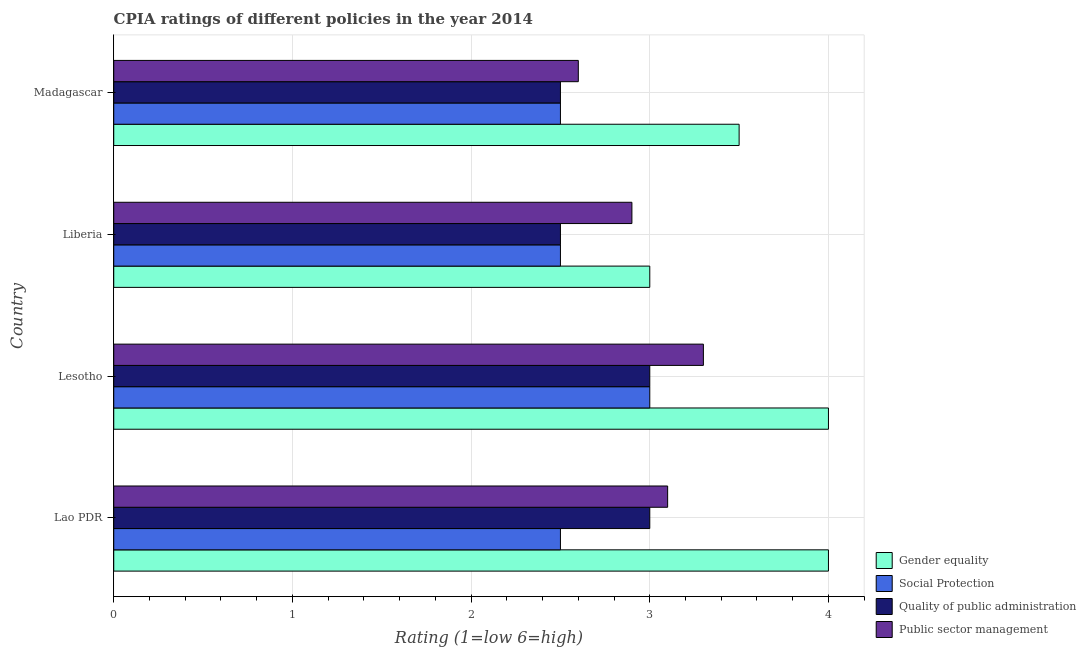How many different coloured bars are there?
Your answer should be compact. 4. How many groups of bars are there?
Make the answer very short. 4. Are the number of bars per tick equal to the number of legend labels?
Provide a short and direct response. Yes. Are the number of bars on each tick of the Y-axis equal?
Give a very brief answer. Yes. What is the label of the 1st group of bars from the top?
Your response must be concise. Madagascar. What is the cpia rating of quality of public administration in Madagascar?
Keep it short and to the point. 2.5. Across all countries, what is the maximum cpia rating of social protection?
Make the answer very short. 3. Across all countries, what is the minimum cpia rating of public sector management?
Give a very brief answer. 2.6. In which country was the cpia rating of gender equality maximum?
Give a very brief answer. Lao PDR. In which country was the cpia rating of social protection minimum?
Make the answer very short. Lao PDR. What is the total cpia rating of public sector management in the graph?
Provide a succinct answer. 11.9. What is the difference between the cpia rating of social protection in Lao PDR and that in Liberia?
Make the answer very short. 0. What is the difference between the cpia rating of social protection in Lao PDR and the cpia rating of public sector management in Liberia?
Offer a terse response. -0.4. What is the average cpia rating of quality of public administration per country?
Give a very brief answer. 2.75. What is the difference between the cpia rating of public sector management and cpia rating of quality of public administration in Lesotho?
Keep it short and to the point. 0.3. In how many countries, is the cpia rating of social protection greater than 0.4 ?
Keep it short and to the point. 4. What is the ratio of the cpia rating of social protection in Liberia to that in Madagascar?
Ensure brevity in your answer.  1. What is the difference between the highest and the second highest cpia rating of social protection?
Give a very brief answer. 0.5. In how many countries, is the cpia rating of quality of public administration greater than the average cpia rating of quality of public administration taken over all countries?
Ensure brevity in your answer.  2. What does the 4th bar from the top in Lesotho represents?
Offer a terse response. Gender equality. What does the 2nd bar from the bottom in Lao PDR represents?
Offer a terse response. Social Protection. Is it the case that in every country, the sum of the cpia rating of gender equality and cpia rating of social protection is greater than the cpia rating of quality of public administration?
Provide a succinct answer. Yes. How many countries are there in the graph?
Keep it short and to the point. 4. Does the graph contain grids?
Offer a terse response. Yes. Where does the legend appear in the graph?
Keep it short and to the point. Bottom right. How many legend labels are there?
Your response must be concise. 4. How are the legend labels stacked?
Give a very brief answer. Vertical. What is the title of the graph?
Ensure brevity in your answer.  CPIA ratings of different policies in the year 2014. What is the label or title of the X-axis?
Keep it short and to the point. Rating (1=low 6=high). What is the label or title of the Y-axis?
Keep it short and to the point. Country. What is the Rating (1=low 6=high) of Quality of public administration in Lao PDR?
Make the answer very short. 3. What is the Rating (1=low 6=high) in Social Protection in Lesotho?
Your answer should be very brief. 3. What is the Rating (1=low 6=high) in Quality of public administration in Lesotho?
Provide a succinct answer. 3. What is the Rating (1=low 6=high) in Gender equality in Liberia?
Your answer should be compact. 3. What is the Rating (1=low 6=high) of Social Protection in Liberia?
Provide a succinct answer. 2.5. What is the Rating (1=low 6=high) in Gender equality in Madagascar?
Give a very brief answer. 3.5. What is the Rating (1=low 6=high) of Social Protection in Madagascar?
Your response must be concise. 2.5. What is the Rating (1=low 6=high) of Quality of public administration in Madagascar?
Your response must be concise. 2.5. Across all countries, what is the maximum Rating (1=low 6=high) of Social Protection?
Your answer should be very brief. 3. Across all countries, what is the maximum Rating (1=low 6=high) in Quality of public administration?
Give a very brief answer. 3. Across all countries, what is the minimum Rating (1=low 6=high) of Social Protection?
Your answer should be very brief. 2.5. Across all countries, what is the minimum Rating (1=low 6=high) of Public sector management?
Your answer should be very brief. 2.6. What is the total Rating (1=low 6=high) of Gender equality in the graph?
Provide a succinct answer. 14.5. What is the total Rating (1=low 6=high) of Quality of public administration in the graph?
Provide a succinct answer. 11. What is the total Rating (1=low 6=high) of Public sector management in the graph?
Provide a short and direct response. 11.9. What is the difference between the Rating (1=low 6=high) in Quality of public administration in Lao PDR and that in Lesotho?
Make the answer very short. 0. What is the difference between the Rating (1=low 6=high) of Public sector management in Lao PDR and that in Lesotho?
Ensure brevity in your answer.  -0.2. What is the difference between the Rating (1=low 6=high) in Gender equality in Lao PDR and that in Liberia?
Offer a very short reply. 1. What is the difference between the Rating (1=low 6=high) in Quality of public administration in Lao PDR and that in Liberia?
Ensure brevity in your answer.  0.5. What is the difference between the Rating (1=low 6=high) of Social Protection in Lao PDR and that in Madagascar?
Your answer should be compact. 0. What is the difference between the Rating (1=low 6=high) of Gender equality in Lesotho and that in Liberia?
Your answer should be very brief. 1. What is the difference between the Rating (1=low 6=high) in Social Protection in Lesotho and that in Madagascar?
Ensure brevity in your answer.  0.5. What is the difference between the Rating (1=low 6=high) in Public sector management in Lesotho and that in Madagascar?
Provide a succinct answer. 0.7. What is the difference between the Rating (1=low 6=high) in Gender equality in Liberia and that in Madagascar?
Your answer should be compact. -0.5. What is the difference between the Rating (1=low 6=high) of Social Protection in Liberia and that in Madagascar?
Your answer should be compact. 0. What is the difference between the Rating (1=low 6=high) in Quality of public administration in Liberia and that in Madagascar?
Provide a short and direct response. 0. What is the difference between the Rating (1=low 6=high) in Gender equality in Lao PDR and the Rating (1=low 6=high) in Public sector management in Lesotho?
Offer a very short reply. 0.7. What is the difference between the Rating (1=low 6=high) in Social Protection in Lao PDR and the Rating (1=low 6=high) in Public sector management in Lesotho?
Ensure brevity in your answer.  -0.8. What is the difference between the Rating (1=low 6=high) in Gender equality in Lao PDR and the Rating (1=low 6=high) in Social Protection in Liberia?
Make the answer very short. 1.5. What is the difference between the Rating (1=low 6=high) of Gender equality in Lao PDR and the Rating (1=low 6=high) of Quality of public administration in Liberia?
Offer a terse response. 1.5. What is the difference between the Rating (1=low 6=high) of Gender equality in Lao PDR and the Rating (1=low 6=high) of Public sector management in Liberia?
Ensure brevity in your answer.  1.1. What is the difference between the Rating (1=low 6=high) in Social Protection in Lao PDR and the Rating (1=low 6=high) in Quality of public administration in Liberia?
Offer a very short reply. 0. What is the difference between the Rating (1=low 6=high) in Social Protection in Lao PDR and the Rating (1=low 6=high) in Public sector management in Liberia?
Provide a short and direct response. -0.4. What is the difference between the Rating (1=low 6=high) in Quality of public administration in Lao PDR and the Rating (1=low 6=high) in Public sector management in Liberia?
Ensure brevity in your answer.  0.1. What is the difference between the Rating (1=low 6=high) in Gender equality in Lao PDR and the Rating (1=low 6=high) in Social Protection in Madagascar?
Your answer should be compact. 1.5. What is the difference between the Rating (1=low 6=high) in Gender equality in Lao PDR and the Rating (1=low 6=high) in Quality of public administration in Madagascar?
Offer a very short reply. 1.5. What is the difference between the Rating (1=low 6=high) in Quality of public administration in Lao PDR and the Rating (1=low 6=high) in Public sector management in Madagascar?
Make the answer very short. 0.4. What is the difference between the Rating (1=low 6=high) in Gender equality in Lesotho and the Rating (1=low 6=high) in Social Protection in Liberia?
Make the answer very short. 1.5. What is the difference between the Rating (1=low 6=high) in Gender equality in Lesotho and the Rating (1=low 6=high) in Quality of public administration in Liberia?
Your response must be concise. 1.5. What is the difference between the Rating (1=low 6=high) in Quality of public administration in Lesotho and the Rating (1=low 6=high) in Public sector management in Liberia?
Your response must be concise. 0.1. What is the difference between the Rating (1=low 6=high) in Gender equality in Lesotho and the Rating (1=low 6=high) in Quality of public administration in Madagascar?
Make the answer very short. 1.5. What is the difference between the Rating (1=low 6=high) of Gender equality in Lesotho and the Rating (1=low 6=high) of Public sector management in Madagascar?
Keep it short and to the point. 1.4. What is the difference between the Rating (1=low 6=high) in Social Protection in Lesotho and the Rating (1=low 6=high) in Quality of public administration in Madagascar?
Keep it short and to the point. 0.5. What is the difference between the Rating (1=low 6=high) in Social Protection in Lesotho and the Rating (1=low 6=high) in Public sector management in Madagascar?
Keep it short and to the point. 0.4. What is the difference between the Rating (1=low 6=high) in Quality of public administration in Lesotho and the Rating (1=low 6=high) in Public sector management in Madagascar?
Offer a terse response. 0.4. What is the difference between the Rating (1=low 6=high) in Gender equality in Liberia and the Rating (1=low 6=high) in Quality of public administration in Madagascar?
Your response must be concise. 0.5. What is the difference between the Rating (1=low 6=high) in Gender equality in Liberia and the Rating (1=low 6=high) in Public sector management in Madagascar?
Provide a succinct answer. 0.4. What is the difference between the Rating (1=low 6=high) of Social Protection in Liberia and the Rating (1=low 6=high) of Quality of public administration in Madagascar?
Give a very brief answer. 0. What is the difference between the Rating (1=low 6=high) in Quality of public administration in Liberia and the Rating (1=low 6=high) in Public sector management in Madagascar?
Keep it short and to the point. -0.1. What is the average Rating (1=low 6=high) of Gender equality per country?
Your answer should be compact. 3.62. What is the average Rating (1=low 6=high) of Social Protection per country?
Provide a succinct answer. 2.62. What is the average Rating (1=low 6=high) of Quality of public administration per country?
Give a very brief answer. 2.75. What is the average Rating (1=low 6=high) in Public sector management per country?
Provide a succinct answer. 2.98. What is the difference between the Rating (1=low 6=high) of Gender equality and Rating (1=low 6=high) of Quality of public administration in Lao PDR?
Your response must be concise. 1. What is the difference between the Rating (1=low 6=high) of Social Protection and Rating (1=low 6=high) of Quality of public administration in Lao PDR?
Provide a short and direct response. -0.5. What is the difference between the Rating (1=low 6=high) of Social Protection and Rating (1=low 6=high) of Public sector management in Lao PDR?
Your response must be concise. -0.6. What is the difference between the Rating (1=low 6=high) in Gender equality and Rating (1=low 6=high) in Quality of public administration in Lesotho?
Offer a terse response. 1. What is the difference between the Rating (1=low 6=high) of Social Protection and Rating (1=low 6=high) of Quality of public administration in Lesotho?
Offer a very short reply. 0. What is the difference between the Rating (1=low 6=high) in Social Protection and Rating (1=low 6=high) in Public sector management in Lesotho?
Ensure brevity in your answer.  -0.3. What is the difference between the Rating (1=low 6=high) in Gender equality and Rating (1=low 6=high) in Quality of public administration in Liberia?
Make the answer very short. 0.5. What is the difference between the Rating (1=low 6=high) in Quality of public administration and Rating (1=low 6=high) in Public sector management in Liberia?
Make the answer very short. -0.4. What is the difference between the Rating (1=low 6=high) of Gender equality and Rating (1=low 6=high) of Social Protection in Madagascar?
Provide a short and direct response. 1. What is the difference between the Rating (1=low 6=high) in Gender equality and Rating (1=low 6=high) in Quality of public administration in Madagascar?
Offer a very short reply. 1. What is the difference between the Rating (1=low 6=high) in Gender equality and Rating (1=low 6=high) in Public sector management in Madagascar?
Offer a terse response. 0.9. What is the difference between the Rating (1=low 6=high) of Social Protection and Rating (1=low 6=high) of Quality of public administration in Madagascar?
Ensure brevity in your answer.  0. What is the difference between the Rating (1=low 6=high) of Social Protection and Rating (1=low 6=high) of Public sector management in Madagascar?
Your answer should be compact. -0.1. What is the difference between the Rating (1=low 6=high) of Quality of public administration and Rating (1=low 6=high) of Public sector management in Madagascar?
Your response must be concise. -0.1. What is the ratio of the Rating (1=low 6=high) of Social Protection in Lao PDR to that in Lesotho?
Ensure brevity in your answer.  0.83. What is the ratio of the Rating (1=low 6=high) in Public sector management in Lao PDR to that in Lesotho?
Offer a terse response. 0.94. What is the ratio of the Rating (1=low 6=high) in Social Protection in Lao PDR to that in Liberia?
Your response must be concise. 1. What is the ratio of the Rating (1=low 6=high) in Quality of public administration in Lao PDR to that in Liberia?
Your response must be concise. 1.2. What is the ratio of the Rating (1=low 6=high) in Public sector management in Lao PDR to that in Liberia?
Your answer should be very brief. 1.07. What is the ratio of the Rating (1=low 6=high) of Social Protection in Lao PDR to that in Madagascar?
Give a very brief answer. 1. What is the ratio of the Rating (1=low 6=high) in Public sector management in Lao PDR to that in Madagascar?
Offer a very short reply. 1.19. What is the ratio of the Rating (1=low 6=high) in Gender equality in Lesotho to that in Liberia?
Keep it short and to the point. 1.33. What is the ratio of the Rating (1=low 6=high) in Quality of public administration in Lesotho to that in Liberia?
Keep it short and to the point. 1.2. What is the ratio of the Rating (1=low 6=high) in Public sector management in Lesotho to that in Liberia?
Your answer should be very brief. 1.14. What is the ratio of the Rating (1=low 6=high) in Social Protection in Lesotho to that in Madagascar?
Offer a very short reply. 1.2. What is the ratio of the Rating (1=low 6=high) of Public sector management in Lesotho to that in Madagascar?
Ensure brevity in your answer.  1.27. What is the ratio of the Rating (1=low 6=high) in Gender equality in Liberia to that in Madagascar?
Give a very brief answer. 0.86. What is the ratio of the Rating (1=low 6=high) of Social Protection in Liberia to that in Madagascar?
Offer a very short reply. 1. What is the ratio of the Rating (1=low 6=high) of Quality of public administration in Liberia to that in Madagascar?
Provide a succinct answer. 1. What is the ratio of the Rating (1=low 6=high) in Public sector management in Liberia to that in Madagascar?
Provide a succinct answer. 1.12. What is the difference between the highest and the second highest Rating (1=low 6=high) of Quality of public administration?
Your answer should be very brief. 0. What is the difference between the highest and the lowest Rating (1=low 6=high) of Social Protection?
Offer a very short reply. 0.5. 